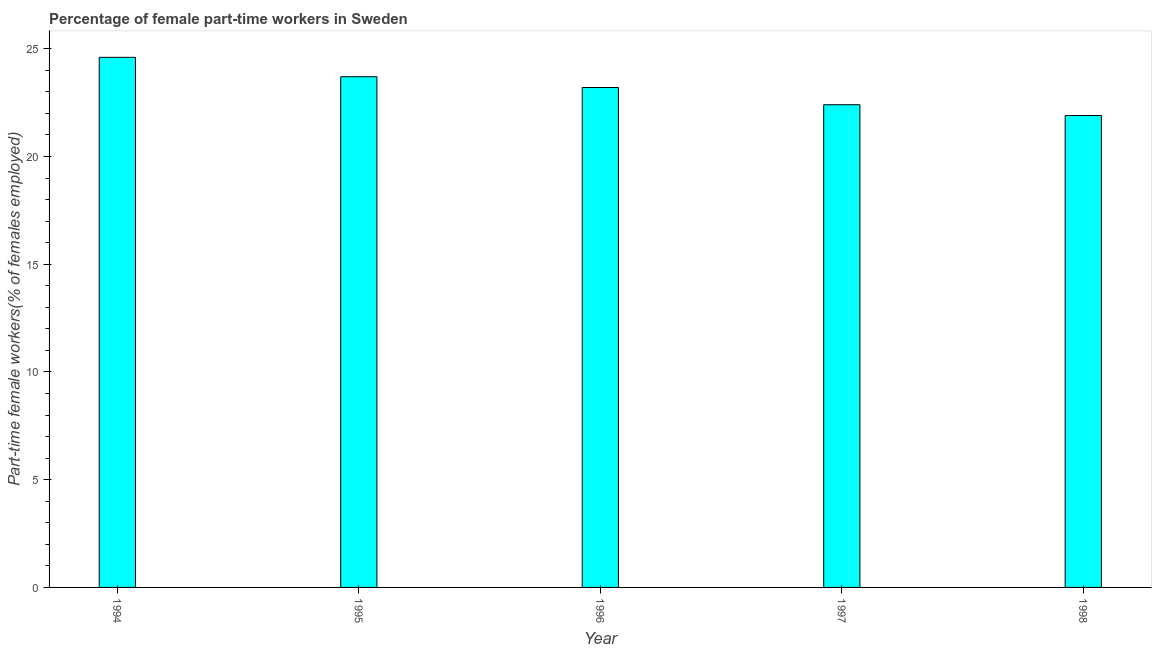Does the graph contain any zero values?
Make the answer very short. No. What is the title of the graph?
Offer a terse response. Percentage of female part-time workers in Sweden. What is the label or title of the Y-axis?
Provide a succinct answer. Part-time female workers(% of females employed). What is the percentage of part-time female workers in 1997?
Give a very brief answer. 22.4. Across all years, what is the maximum percentage of part-time female workers?
Provide a succinct answer. 24.6. Across all years, what is the minimum percentage of part-time female workers?
Keep it short and to the point. 21.9. In which year was the percentage of part-time female workers minimum?
Offer a very short reply. 1998. What is the sum of the percentage of part-time female workers?
Provide a succinct answer. 115.8. What is the difference between the percentage of part-time female workers in 1994 and 1995?
Your answer should be very brief. 0.9. What is the average percentage of part-time female workers per year?
Give a very brief answer. 23.16. What is the median percentage of part-time female workers?
Offer a very short reply. 23.2. In how many years, is the percentage of part-time female workers greater than 19 %?
Ensure brevity in your answer.  5. Do a majority of the years between 1995 and 1997 (inclusive) have percentage of part-time female workers greater than 5 %?
Provide a succinct answer. Yes. What is the ratio of the percentage of part-time female workers in 1994 to that in 1995?
Offer a very short reply. 1.04. Is the difference between the percentage of part-time female workers in 1995 and 1998 greater than the difference between any two years?
Give a very brief answer. No. What is the difference between the highest and the second highest percentage of part-time female workers?
Offer a terse response. 0.9. Is the sum of the percentage of part-time female workers in 1994 and 1996 greater than the maximum percentage of part-time female workers across all years?
Keep it short and to the point. Yes. In how many years, is the percentage of part-time female workers greater than the average percentage of part-time female workers taken over all years?
Provide a succinct answer. 3. How many bars are there?
Provide a succinct answer. 5. How many years are there in the graph?
Offer a terse response. 5. What is the difference between two consecutive major ticks on the Y-axis?
Give a very brief answer. 5. What is the Part-time female workers(% of females employed) of 1994?
Keep it short and to the point. 24.6. What is the Part-time female workers(% of females employed) in 1995?
Provide a succinct answer. 23.7. What is the Part-time female workers(% of females employed) in 1996?
Provide a succinct answer. 23.2. What is the Part-time female workers(% of females employed) in 1997?
Offer a very short reply. 22.4. What is the Part-time female workers(% of females employed) in 1998?
Your answer should be very brief. 21.9. What is the difference between the Part-time female workers(% of females employed) in 1994 and 1998?
Make the answer very short. 2.7. What is the difference between the Part-time female workers(% of females employed) in 1995 and 1996?
Offer a terse response. 0.5. What is the difference between the Part-time female workers(% of females employed) in 1995 and 1998?
Your answer should be compact. 1.8. What is the difference between the Part-time female workers(% of females employed) in 1996 and 1997?
Make the answer very short. 0.8. What is the ratio of the Part-time female workers(% of females employed) in 1994 to that in 1995?
Your response must be concise. 1.04. What is the ratio of the Part-time female workers(% of females employed) in 1994 to that in 1996?
Offer a very short reply. 1.06. What is the ratio of the Part-time female workers(% of females employed) in 1994 to that in 1997?
Your answer should be compact. 1.1. What is the ratio of the Part-time female workers(% of females employed) in 1994 to that in 1998?
Your response must be concise. 1.12. What is the ratio of the Part-time female workers(% of females employed) in 1995 to that in 1996?
Your answer should be very brief. 1.02. What is the ratio of the Part-time female workers(% of females employed) in 1995 to that in 1997?
Ensure brevity in your answer.  1.06. What is the ratio of the Part-time female workers(% of females employed) in 1995 to that in 1998?
Provide a short and direct response. 1.08. What is the ratio of the Part-time female workers(% of females employed) in 1996 to that in 1997?
Your answer should be compact. 1.04. What is the ratio of the Part-time female workers(% of females employed) in 1996 to that in 1998?
Provide a succinct answer. 1.06. 